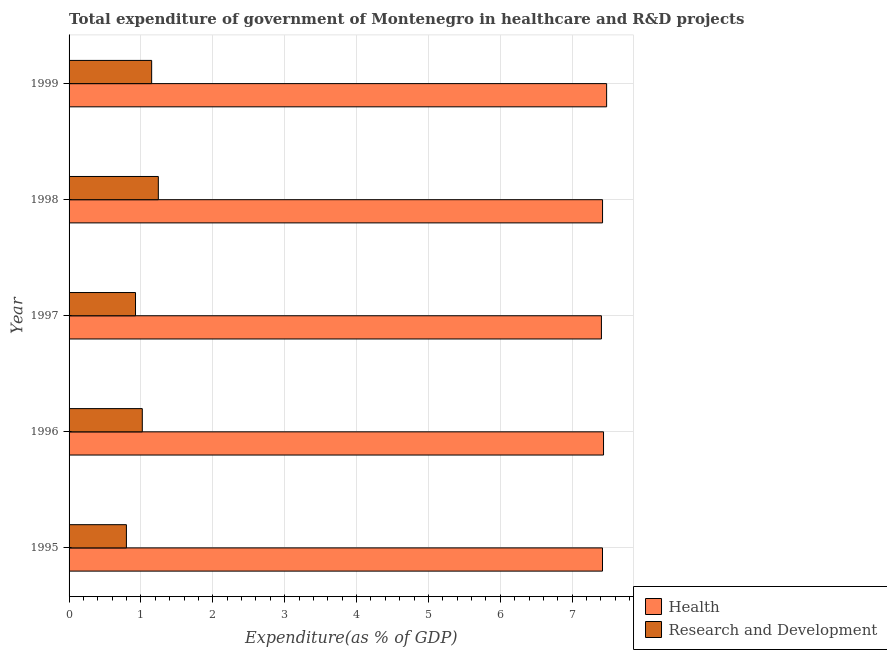How many groups of bars are there?
Provide a short and direct response. 5. What is the label of the 1st group of bars from the top?
Provide a succinct answer. 1999. What is the expenditure in healthcare in 1996?
Offer a very short reply. 7.44. Across all years, what is the maximum expenditure in r&d?
Your response must be concise. 1.24. Across all years, what is the minimum expenditure in r&d?
Your response must be concise. 0.8. In which year was the expenditure in healthcare maximum?
Offer a terse response. 1999. What is the total expenditure in r&d in the graph?
Your answer should be compact. 5.13. What is the difference between the expenditure in healthcare in 1995 and that in 1999?
Provide a succinct answer. -0.06. What is the difference between the expenditure in healthcare in 1997 and the expenditure in r&d in 1996?
Provide a succinct answer. 6.39. In the year 1997, what is the difference between the expenditure in healthcare and expenditure in r&d?
Make the answer very short. 6.48. In how many years, is the expenditure in healthcare greater than 1 %?
Your response must be concise. 5. What is the difference between the highest and the second highest expenditure in healthcare?
Keep it short and to the point. 0.04. What is the difference between the highest and the lowest expenditure in r&d?
Make the answer very short. 0.44. What does the 1st bar from the top in 1997 represents?
Provide a succinct answer. Research and Development. What does the 1st bar from the bottom in 1998 represents?
Provide a short and direct response. Health. How many bars are there?
Your answer should be compact. 10. What is the difference between two consecutive major ticks on the X-axis?
Offer a very short reply. 1. How many legend labels are there?
Give a very brief answer. 2. How are the legend labels stacked?
Offer a terse response. Vertical. What is the title of the graph?
Offer a very short reply. Total expenditure of government of Montenegro in healthcare and R&D projects. Does "Age 15+" appear as one of the legend labels in the graph?
Ensure brevity in your answer.  No. What is the label or title of the X-axis?
Your answer should be very brief. Expenditure(as % of GDP). What is the label or title of the Y-axis?
Provide a short and direct response. Year. What is the Expenditure(as % of GDP) of Health in 1995?
Offer a very short reply. 7.42. What is the Expenditure(as % of GDP) of Research and Development in 1995?
Your response must be concise. 0.8. What is the Expenditure(as % of GDP) in Health in 1996?
Your response must be concise. 7.44. What is the Expenditure(as % of GDP) of Research and Development in 1996?
Your response must be concise. 1.02. What is the Expenditure(as % of GDP) in Health in 1997?
Provide a succinct answer. 7.41. What is the Expenditure(as % of GDP) of Research and Development in 1997?
Your answer should be very brief. 0.92. What is the Expenditure(as % of GDP) in Health in 1998?
Offer a very short reply. 7.42. What is the Expenditure(as % of GDP) of Research and Development in 1998?
Keep it short and to the point. 1.24. What is the Expenditure(as % of GDP) in Health in 1999?
Offer a terse response. 7.48. What is the Expenditure(as % of GDP) of Research and Development in 1999?
Keep it short and to the point. 1.15. Across all years, what is the maximum Expenditure(as % of GDP) in Health?
Provide a short and direct response. 7.48. Across all years, what is the maximum Expenditure(as % of GDP) in Research and Development?
Offer a very short reply. 1.24. Across all years, what is the minimum Expenditure(as % of GDP) of Health?
Offer a very short reply. 7.41. Across all years, what is the minimum Expenditure(as % of GDP) in Research and Development?
Make the answer very short. 0.8. What is the total Expenditure(as % of GDP) in Health in the graph?
Provide a short and direct response. 37.16. What is the total Expenditure(as % of GDP) of Research and Development in the graph?
Make the answer very short. 5.13. What is the difference between the Expenditure(as % of GDP) in Health in 1995 and that in 1996?
Keep it short and to the point. -0.01. What is the difference between the Expenditure(as % of GDP) in Research and Development in 1995 and that in 1996?
Offer a very short reply. -0.22. What is the difference between the Expenditure(as % of GDP) in Health in 1995 and that in 1997?
Keep it short and to the point. 0.01. What is the difference between the Expenditure(as % of GDP) in Research and Development in 1995 and that in 1997?
Your answer should be compact. -0.13. What is the difference between the Expenditure(as % of GDP) of Health in 1995 and that in 1998?
Offer a terse response. -0. What is the difference between the Expenditure(as % of GDP) of Research and Development in 1995 and that in 1998?
Ensure brevity in your answer.  -0.44. What is the difference between the Expenditure(as % of GDP) of Health in 1995 and that in 1999?
Make the answer very short. -0.06. What is the difference between the Expenditure(as % of GDP) of Research and Development in 1995 and that in 1999?
Your response must be concise. -0.35. What is the difference between the Expenditure(as % of GDP) in Health in 1996 and that in 1997?
Your response must be concise. 0.03. What is the difference between the Expenditure(as % of GDP) of Research and Development in 1996 and that in 1997?
Give a very brief answer. 0.09. What is the difference between the Expenditure(as % of GDP) in Health in 1996 and that in 1998?
Make the answer very short. 0.01. What is the difference between the Expenditure(as % of GDP) in Research and Development in 1996 and that in 1998?
Provide a succinct answer. -0.22. What is the difference between the Expenditure(as % of GDP) in Health in 1996 and that in 1999?
Keep it short and to the point. -0.04. What is the difference between the Expenditure(as % of GDP) of Research and Development in 1996 and that in 1999?
Provide a short and direct response. -0.13. What is the difference between the Expenditure(as % of GDP) in Health in 1997 and that in 1998?
Offer a very short reply. -0.02. What is the difference between the Expenditure(as % of GDP) of Research and Development in 1997 and that in 1998?
Keep it short and to the point. -0.32. What is the difference between the Expenditure(as % of GDP) in Health in 1997 and that in 1999?
Offer a very short reply. -0.07. What is the difference between the Expenditure(as % of GDP) of Research and Development in 1997 and that in 1999?
Your response must be concise. -0.22. What is the difference between the Expenditure(as % of GDP) in Health in 1998 and that in 1999?
Provide a short and direct response. -0.06. What is the difference between the Expenditure(as % of GDP) of Research and Development in 1998 and that in 1999?
Provide a short and direct response. 0.09. What is the difference between the Expenditure(as % of GDP) of Health in 1995 and the Expenditure(as % of GDP) of Research and Development in 1996?
Provide a succinct answer. 6.4. What is the difference between the Expenditure(as % of GDP) in Health in 1995 and the Expenditure(as % of GDP) in Research and Development in 1997?
Make the answer very short. 6.5. What is the difference between the Expenditure(as % of GDP) in Health in 1995 and the Expenditure(as % of GDP) in Research and Development in 1998?
Your response must be concise. 6.18. What is the difference between the Expenditure(as % of GDP) of Health in 1995 and the Expenditure(as % of GDP) of Research and Development in 1999?
Your response must be concise. 6.27. What is the difference between the Expenditure(as % of GDP) of Health in 1996 and the Expenditure(as % of GDP) of Research and Development in 1997?
Keep it short and to the point. 6.51. What is the difference between the Expenditure(as % of GDP) of Health in 1996 and the Expenditure(as % of GDP) of Research and Development in 1998?
Offer a terse response. 6.19. What is the difference between the Expenditure(as % of GDP) of Health in 1996 and the Expenditure(as % of GDP) of Research and Development in 1999?
Give a very brief answer. 6.29. What is the difference between the Expenditure(as % of GDP) in Health in 1997 and the Expenditure(as % of GDP) in Research and Development in 1998?
Provide a short and direct response. 6.16. What is the difference between the Expenditure(as % of GDP) in Health in 1997 and the Expenditure(as % of GDP) in Research and Development in 1999?
Offer a terse response. 6.26. What is the difference between the Expenditure(as % of GDP) in Health in 1998 and the Expenditure(as % of GDP) in Research and Development in 1999?
Your answer should be compact. 6.27. What is the average Expenditure(as % of GDP) of Health per year?
Your answer should be very brief. 7.43. What is the average Expenditure(as % of GDP) in Research and Development per year?
Give a very brief answer. 1.03. In the year 1995, what is the difference between the Expenditure(as % of GDP) in Health and Expenditure(as % of GDP) in Research and Development?
Your answer should be very brief. 6.62. In the year 1996, what is the difference between the Expenditure(as % of GDP) in Health and Expenditure(as % of GDP) in Research and Development?
Your answer should be compact. 6.42. In the year 1997, what is the difference between the Expenditure(as % of GDP) of Health and Expenditure(as % of GDP) of Research and Development?
Offer a terse response. 6.48. In the year 1998, what is the difference between the Expenditure(as % of GDP) in Health and Expenditure(as % of GDP) in Research and Development?
Your answer should be compact. 6.18. In the year 1999, what is the difference between the Expenditure(as % of GDP) of Health and Expenditure(as % of GDP) of Research and Development?
Your answer should be very brief. 6.33. What is the ratio of the Expenditure(as % of GDP) of Research and Development in 1995 to that in 1996?
Give a very brief answer. 0.78. What is the ratio of the Expenditure(as % of GDP) of Health in 1995 to that in 1997?
Your answer should be very brief. 1. What is the ratio of the Expenditure(as % of GDP) in Research and Development in 1995 to that in 1997?
Your answer should be compact. 0.86. What is the ratio of the Expenditure(as % of GDP) of Health in 1995 to that in 1998?
Keep it short and to the point. 1. What is the ratio of the Expenditure(as % of GDP) in Research and Development in 1995 to that in 1998?
Your response must be concise. 0.64. What is the ratio of the Expenditure(as % of GDP) in Health in 1995 to that in 1999?
Make the answer very short. 0.99. What is the ratio of the Expenditure(as % of GDP) in Research and Development in 1995 to that in 1999?
Your response must be concise. 0.69. What is the ratio of the Expenditure(as % of GDP) in Research and Development in 1996 to that in 1997?
Ensure brevity in your answer.  1.1. What is the ratio of the Expenditure(as % of GDP) in Health in 1996 to that in 1998?
Offer a terse response. 1. What is the ratio of the Expenditure(as % of GDP) in Research and Development in 1996 to that in 1998?
Your response must be concise. 0.82. What is the ratio of the Expenditure(as % of GDP) of Research and Development in 1996 to that in 1999?
Make the answer very short. 0.89. What is the ratio of the Expenditure(as % of GDP) of Research and Development in 1997 to that in 1998?
Offer a terse response. 0.74. What is the ratio of the Expenditure(as % of GDP) in Health in 1997 to that in 1999?
Offer a very short reply. 0.99. What is the ratio of the Expenditure(as % of GDP) of Research and Development in 1997 to that in 1999?
Make the answer very short. 0.8. What is the ratio of the Expenditure(as % of GDP) in Research and Development in 1998 to that in 1999?
Your answer should be compact. 1.08. What is the difference between the highest and the second highest Expenditure(as % of GDP) in Health?
Keep it short and to the point. 0.04. What is the difference between the highest and the second highest Expenditure(as % of GDP) of Research and Development?
Offer a very short reply. 0.09. What is the difference between the highest and the lowest Expenditure(as % of GDP) of Health?
Your response must be concise. 0.07. What is the difference between the highest and the lowest Expenditure(as % of GDP) in Research and Development?
Your answer should be compact. 0.44. 